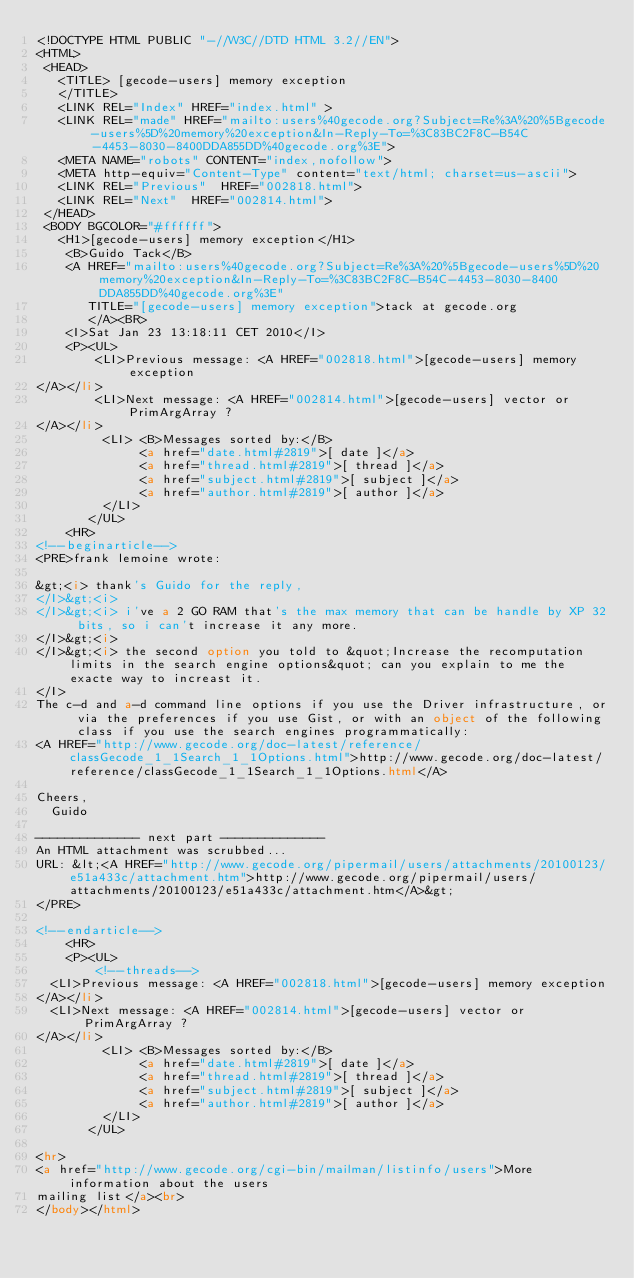Convert code to text. <code><loc_0><loc_0><loc_500><loc_500><_HTML_><!DOCTYPE HTML PUBLIC "-//W3C//DTD HTML 3.2//EN">
<HTML>
 <HEAD>
   <TITLE> [gecode-users] memory exception
   </TITLE>
   <LINK REL="Index" HREF="index.html" >
   <LINK REL="made" HREF="mailto:users%40gecode.org?Subject=Re%3A%20%5Bgecode-users%5D%20memory%20exception&In-Reply-To=%3C83BC2F8C-B54C-4453-8030-8400DDA855DD%40gecode.org%3E">
   <META NAME="robots" CONTENT="index,nofollow">
   <META http-equiv="Content-Type" content="text/html; charset=us-ascii">
   <LINK REL="Previous"  HREF="002818.html">
   <LINK REL="Next"  HREF="002814.html">
 </HEAD>
 <BODY BGCOLOR="#ffffff">
   <H1>[gecode-users] memory exception</H1>
    <B>Guido Tack</B> 
    <A HREF="mailto:users%40gecode.org?Subject=Re%3A%20%5Bgecode-users%5D%20memory%20exception&In-Reply-To=%3C83BC2F8C-B54C-4453-8030-8400DDA855DD%40gecode.org%3E"
       TITLE="[gecode-users] memory exception">tack at gecode.org
       </A><BR>
    <I>Sat Jan 23 13:18:11 CET 2010</I>
    <P><UL>
        <LI>Previous message: <A HREF="002818.html">[gecode-users] memory exception
</A></li>
        <LI>Next message: <A HREF="002814.html">[gecode-users] vector or PrimArgArray ?
</A></li>
         <LI> <B>Messages sorted by:</B> 
              <a href="date.html#2819">[ date ]</a>
              <a href="thread.html#2819">[ thread ]</a>
              <a href="subject.html#2819">[ subject ]</a>
              <a href="author.html#2819">[ author ]</a>
         </LI>
       </UL>
    <HR>  
<!--beginarticle-->
<PRE>frank lemoine wrote:

&gt;<i> thank's Guido for the reply,
</I>&gt;<i>  
</I>&gt;<i> i've a 2 GO RAM that's the max memory that can be handle by XP 32 bits, so i can't increase it any more.
</I>&gt;<i>  
</I>&gt;<i> the second option you told to &quot;Increase the recomputation limits in the search engine options&quot; can you explain to me the exacte way to increast it.
</I>
The c-d and a-d command line options if you use the Driver infrastructure, or via the preferences if you use Gist, or with an object of the following class if you use the search engines programmatically:
<A HREF="http://www.gecode.org/doc-latest/reference/classGecode_1_1Search_1_1Options.html">http://www.gecode.org/doc-latest/reference/classGecode_1_1Search_1_1Options.html</A>

Cheers,
	Guido

-------------- next part --------------
An HTML attachment was scrubbed...
URL: &lt;<A HREF="http://www.gecode.org/pipermail/users/attachments/20100123/e51a433c/attachment.htm">http://www.gecode.org/pipermail/users/attachments/20100123/e51a433c/attachment.htm</A>&gt;
</PRE>

<!--endarticle-->
    <HR>
    <P><UL>
        <!--threads-->
	<LI>Previous message: <A HREF="002818.html">[gecode-users] memory exception
</A></li>
	<LI>Next message: <A HREF="002814.html">[gecode-users] vector or PrimArgArray ?
</A></li>
         <LI> <B>Messages sorted by:</B> 
              <a href="date.html#2819">[ date ]</a>
              <a href="thread.html#2819">[ thread ]</a>
              <a href="subject.html#2819">[ subject ]</a>
              <a href="author.html#2819">[ author ]</a>
         </LI>
       </UL>

<hr>
<a href="http://www.gecode.org/cgi-bin/mailman/listinfo/users">More information about the users
mailing list</a><br>
</body></html>
</code> 